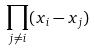<formula> <loc_0><loc_0><loc_500><loc_500>\prod _ { j \ne i } ( x _ { i } - x _ { j } )</formula> 